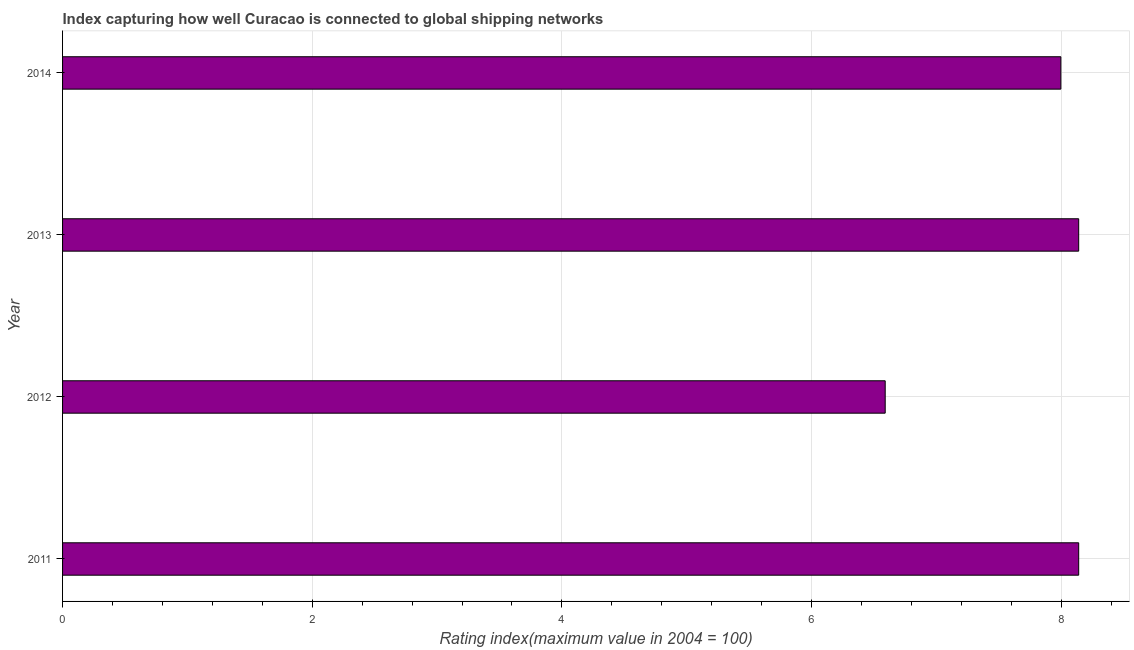Does the graph contain grids?
Give a very brief answer. Yes. What is the title of the graph?
Ensure brevity in your answer.  Index capturing how well Curacao is connected to global shipping networks. What is the label or title of the X-axis?
Give a very brief answer. Rating index(maximum value in 2004 = 100). What is the liner shipping connectivity index in 2012?
Ensure brevity in your answer.  6.59. Across all years, what is the maximum liner shipping connectivity index?
Make the answer very short. 8.14. Across all years, what is the minimum liner shipping connectivity index?
Your answer should be compact. 6.59. In which year was the liner shipping connectivity index maximum?
Offer a very short reply. 2011. In which year was the liner shipping connectivity index minimum?
Offer a very short reply. 2012. What is the sum of the liner shipping connectivity index?
Your answer should be very brief. 30.87. What is the difference between the liner shipping connectivity index in 2011 and 2014?
Provide a succinct answer. 0.14. What is the average liner shipping connectivity index per year?
Make the answer very short. 7.72. What is the median liner shipping connectivity index?
Keep it short and to the point. 8.07. What is the ratio of the liner shipping connectivity index in 2011 to that in 2013?
Your answer should be very brief. 1. Is the liner shipping connectivity index in 2011 less than that in 2014?
Your response must be concise. No. Is the difference between the liner shipping connectivity index in 2011 and 2014 greater than the difference between any two years?
Your answer should be very brief. No. Is the sum of the liner shipping connectivity index in 2011 and 2012 greater than the maximum liner shipping connectivity index across all years?
Keep it short and to the point. Yes. What is the difference between the highest and the lowest liner shipping connectivity index?
Your answer should be very brief. 1.55. In how many years, is the liner shipping connectivity index greater than the average liner shipping connectivity index taken over all years?
Provide a short and direct response. 3. How many bars are there?
Provide a short and direct response. 4. What is the Rating index(maximum value in 2004 = 100) of 2011?
Offer a very short reply. 8.14. What is the Rating index(maximum value in 2004 = 100) in 2012?
Give a very brief answer. 6.59. What is the Rating index(maximum value in 2004 = 100) in 2013?
Make the answer very short. 8.14. What is the Rating index(maximum value in 2004 = 100) in 2014?
Keep it short and to the point. 8. What is the difference between the Rating index(maximum value in 2004 = 100) in 2011 and 2012?
Keep it short and to the point. 1.55. What is the difference between the Rating index(maximum value in 2004 = 100) in 2011 and 2014?
Your answer should be compact. 0.14. What is the difference between the Rating index(maximum value in 2004 = 100) in 2012 and 2013?
Your answer should be very brief. -1.55. What is the difference between the Rating index(maximum value in 2004 = 100) in 2012 and 2014?
Provide a short and direct response. -1.41. What is the difference between the Rating index(maximum value in 2004 = 100) in 2013 and 2014?
Provide a short and direct response. 0.14. What is the ratio of the Rating index(maximum value in 2004 = 100) in 2011 to that in 2012?
Provide a succinct answer. 1.24. What is the ratio of the Rating index(maximum value in 2004 = 100) in 2011 to that in 2014?
Make the answer very short. 1.02. What is the ratio of the Rating index(maximum value in 2004 = 100) in 2012 to that in 2013?
Provide a short and direct response. 0.81. What is the ratio of the Rating index(maximum value in 2004 = 100) in 2012 to that in 2014?
Make the answer very short. 0.82. What is the ratio of the Rating index(maximum value in 2004 = 100) in 2013 to that in 2014?
Offer a very short reply. 1.02. 